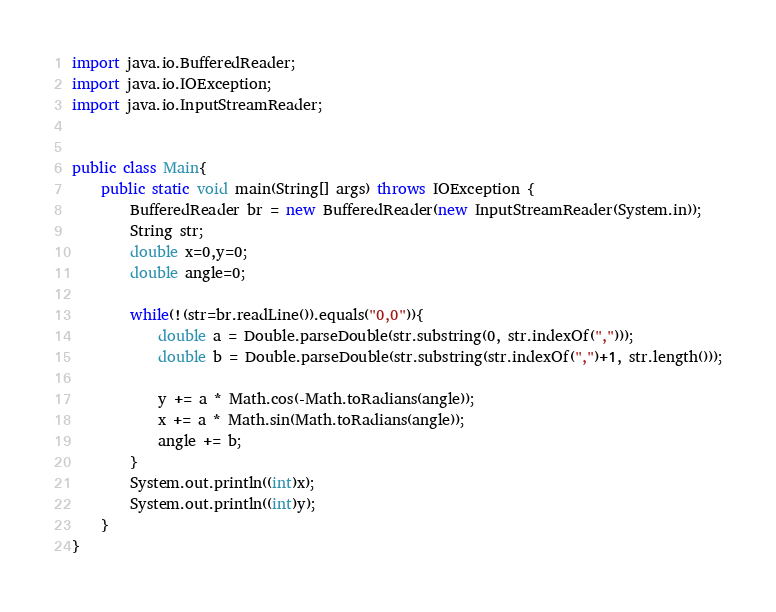<code> <loc_0><loc_0><loc_500><loc_500><_Java_>import java.io.BufferedReader;
import java.io.IOException;
import java.io.InputStreamReader;


public class Main{
	public static void main(String[] args) throws IOException {
		BufferedReader br = new BufferedReader(new InputStreamReader(System.in));
		String str;
		double x=0,y=0;
		double angle=0;

		while(!(str=br.readLine()).equals("0,0")){
			double a = Double.parseDouble(str.substring(0, str.indexOf(",")));
			double b = Double.parseDouble(str.substring(str.indexOf(",")+1, str.length()));

			y += a * Math.cos(-Math.toRadians(angle));
			x += a * Math.sin(Math.toRadians(angle));
			angle += b;
		}
		System.out.println((int)x);
		System.out.println((int)y);
	}
}</code> 